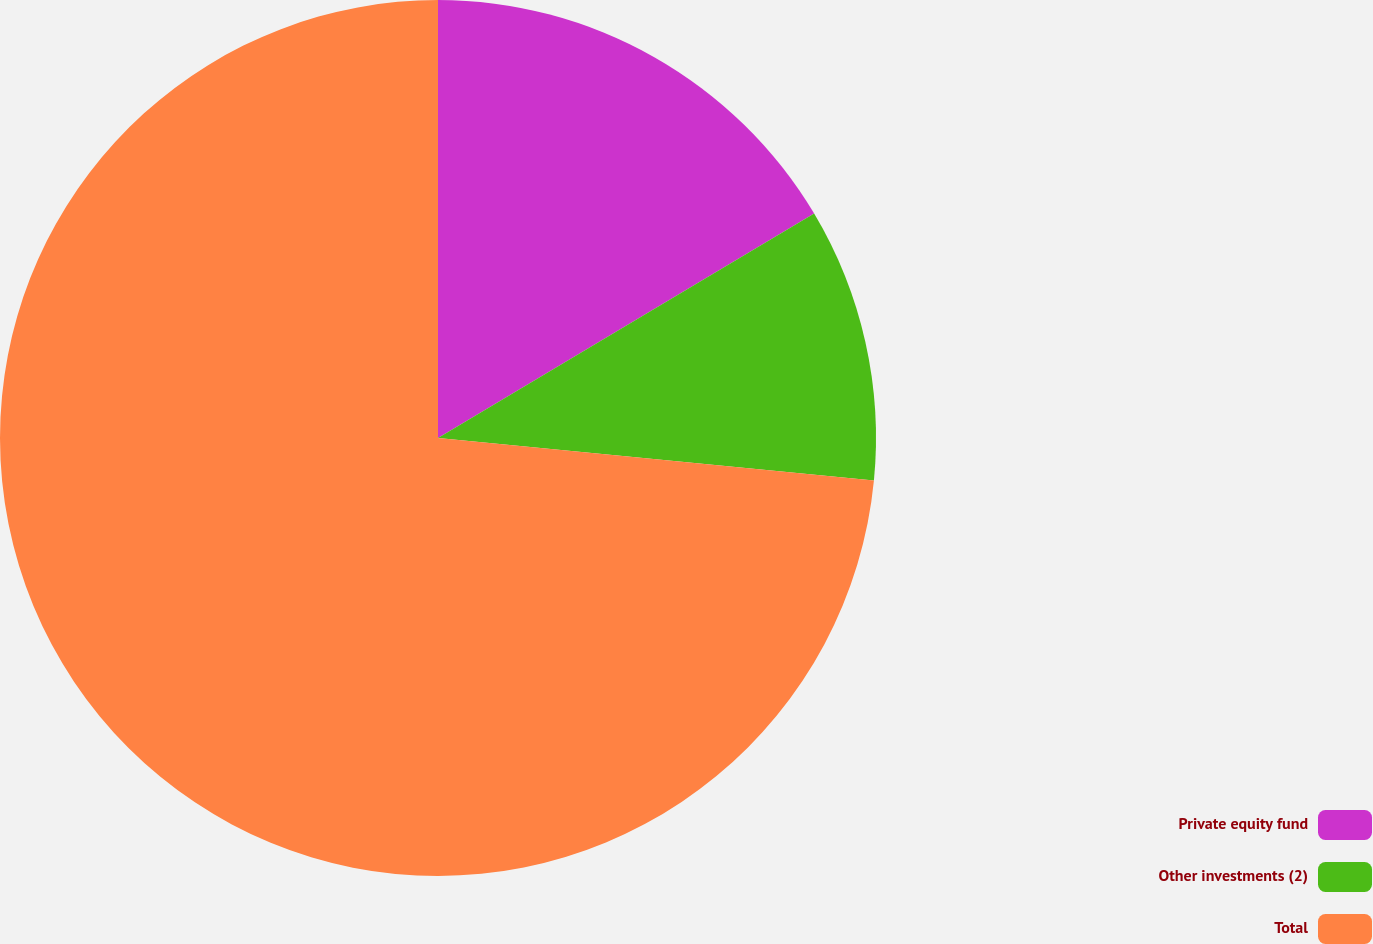<chart> <loc_0><loc_0><loc_500><loc_500><pie_chart><fcel>Private equity fund<fcel>Other investments (2)<fcel>Total<nl><fcel>16.44%<fcel>10.11%<fcel>73.45%<nl></chart> 